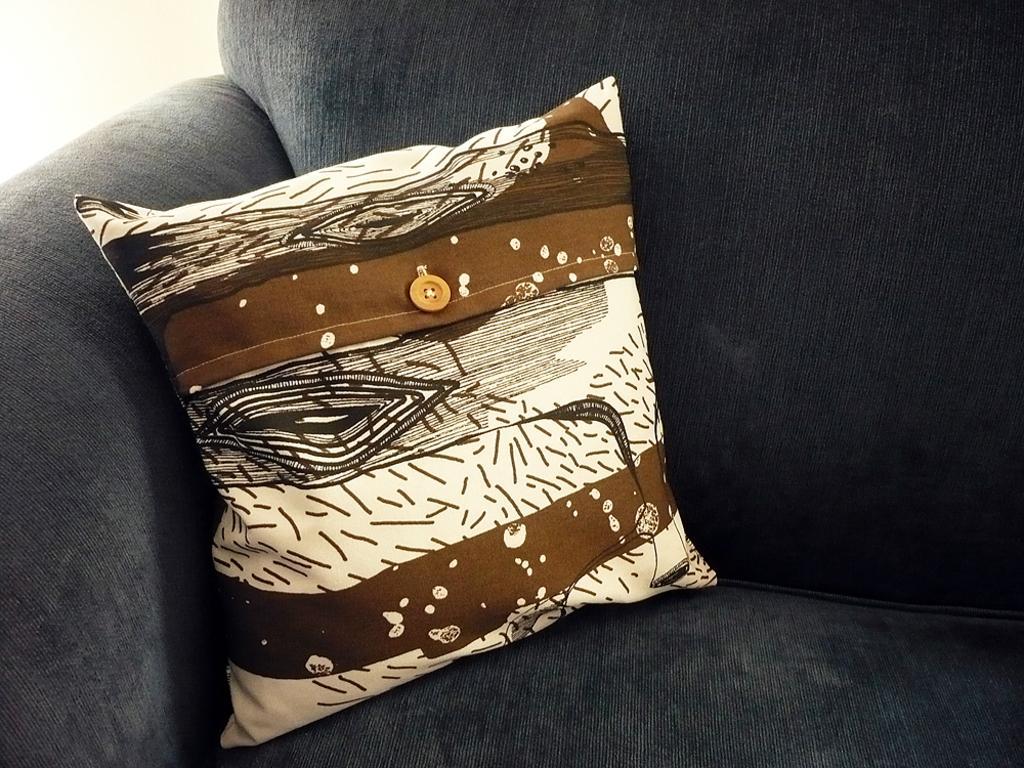How would you summarize this image in a sentence or two? In this image we can see grey color sofa and one brown-white color pillow is kept on it. 